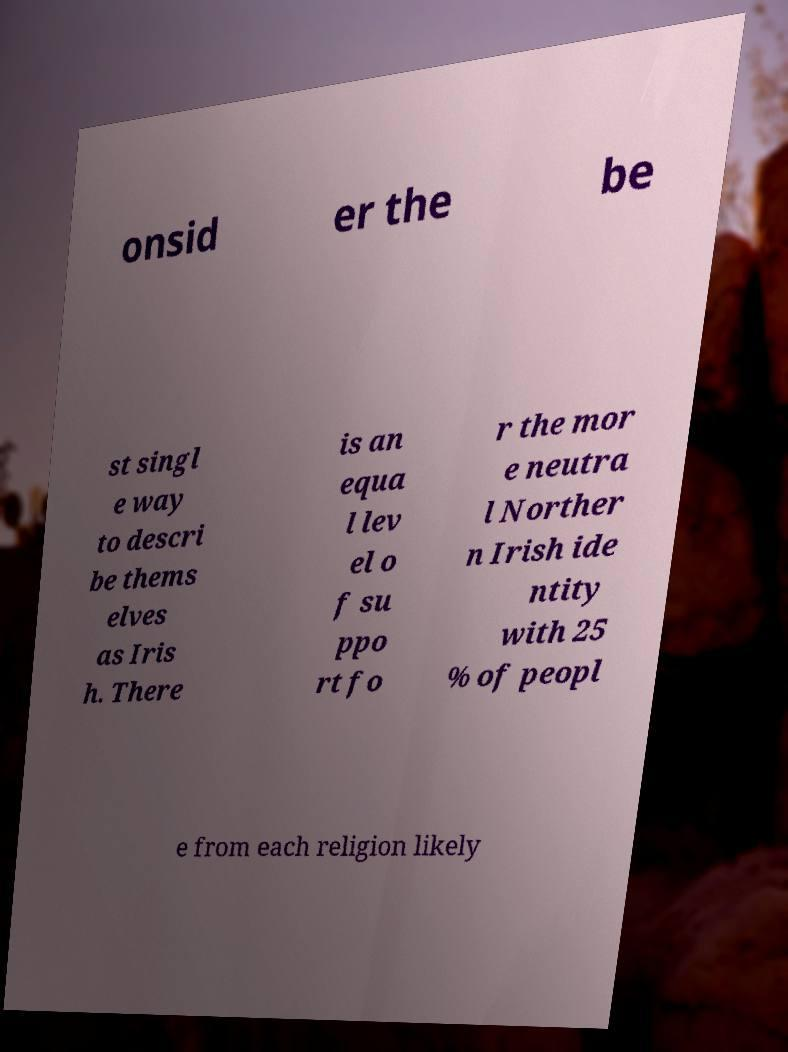There's text embedded in this image that I need extracted. Can you transcribe it verbatim? onsid er the be st singl e way to descri be thems elves as Iris h. There is an equa l lev el o f su ppo rt fo r the mor e neutra l Norther n Irish ide ntity with 25 % of peopl e from each religion likely 